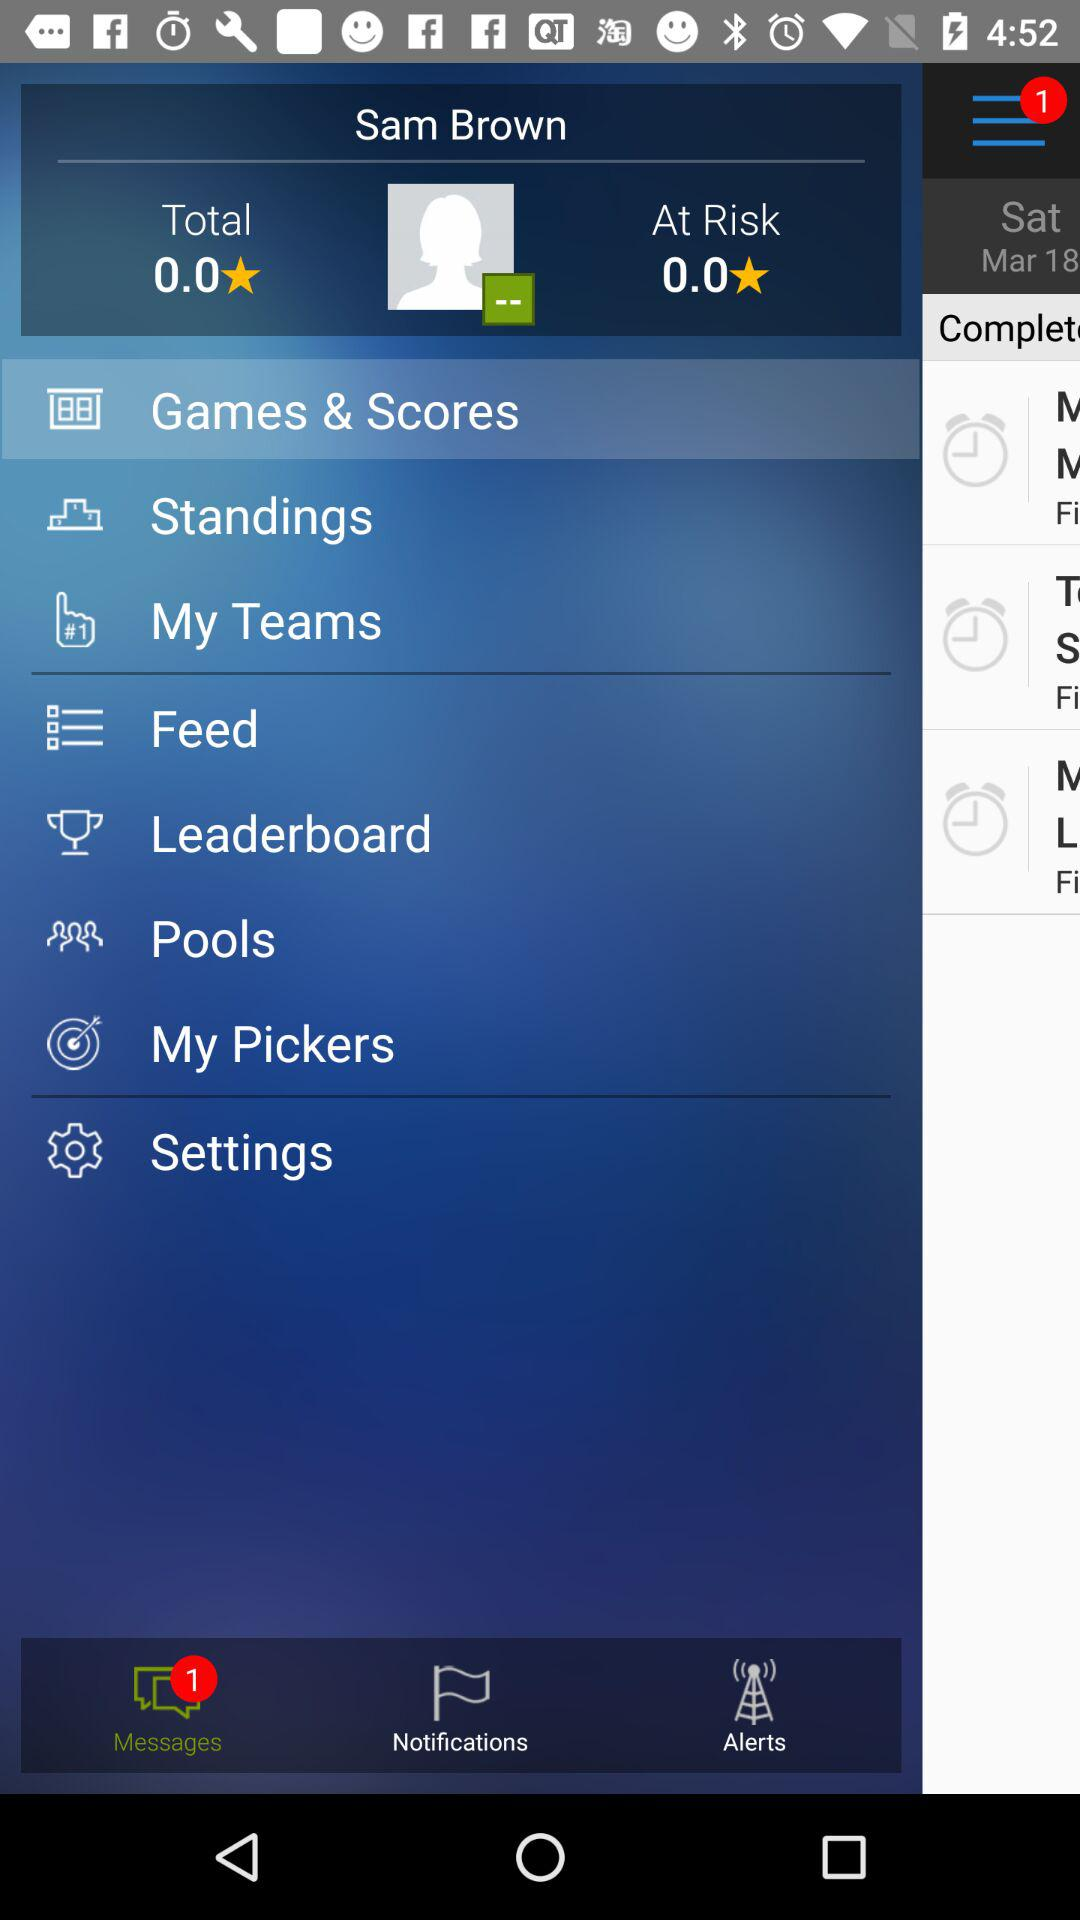What is the count of "At Risk" stars? The count is 0 stars. 